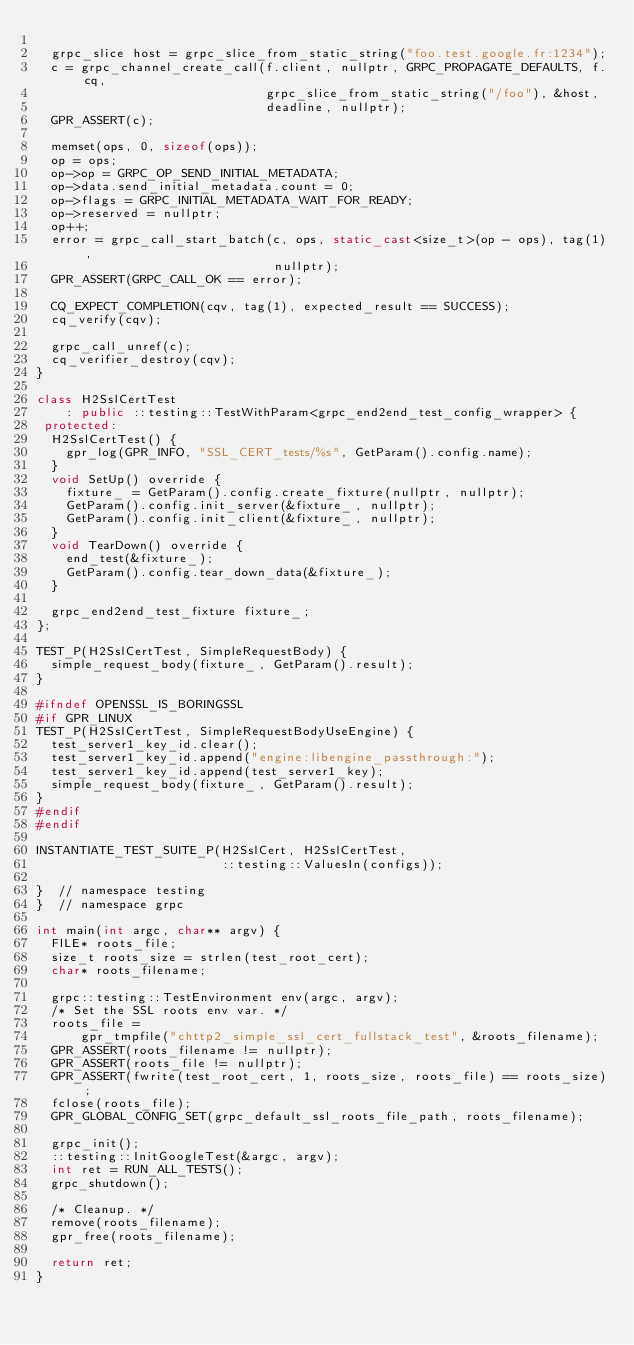Convert code to text. <code><loc_0><loc_0><loc_500><loc_500><_C++_>
  grpc_slice host = grpc_slice_from_static_string("foo.test.google.fr:1234");
  c = grpc_channel_create_call(f.client, nullptr, GRPC_PROPAGATE_DEFAULTS, f.cq,
                               grpc_slice_from_static_string("/foo"), &host,
                               deadline, nullptr);
  GPR_ASSERT(c);

  memset(ops, 0, sizeof(ops));
  op = ops;
  op->op = GRPC_OP_SEND_INITIAL_METADATA;
  op->data.send_initial_metadata.count = 0;
  op->flags = GRPC_INITIAL_METADATA_WAIT_FOR_READY;
  op->reserved = nullptr;
  op++;
  error = grpc_call_start_batch(c, ops, static_cast<size_t>(op - ops), tag(1),
                                nullptr);
  GPR_ASSERT(GRPC_CALL_OK == error);

  CQ_EXPECT_COMPLETION(cqv, tag(1), expected_result == SUCCESS);
  cq_verify(cqv);

  grpc_call_unref(c);
  cq_verifier_destroy(cqv);
}

class H2SslCertTest
    : public ::testing::TestWithParam<grpc_end2end_test_config_wrapper> {
 protected:
  H2SslCertTest() {
    gpr_log(GPR_INFO, "SSL_CERT_tests/%s", GetParam().config.name);
  }
  void SetUp() override {
    fixture_ = GetParam().config.create_fixture(nullptr, nullptr);
    GetParam().config.init_server(&fixture_, nullptr);
    GetParam().config.init_client(&fixture_, nullptr);
  }
  void TearDown() override {
    end_test(&fixture_);
    GetParam().config.tear_down_data(&fixture_);
  }

  grpc_end2end_test_fixture fixture_;
};

TEST_P(H2SslCertTest, SimpleRequestBody) {
  simple_request_body(fixture_, GetParam().result);
}

#ifndef OPENSSL_IS_BORINGSSL
#if GPR_LINUX
TEST_P(H2SslCertTest, SimpleRequestBodyUseEngine) {
  test_server1_key_id.clear();
  test_server1_key_id.append("engine:libengine_passthrough:");
  test_server1_key_id.append(test_server1_key);
  simple_request_body(fixture_, GetParam().result);
}
#endif
#endif

INSTANTIATE_TEST_SUITE_P(H2SslCert, H2SslCertTest,
                         ::testing::ValuesIn(configs));

}  // namespace testing
}  // namespace grpc

int main(int argc, char** argv) {
  FILE* roots_file;
  size_t roots_size = strlen(test_root_cert);
  char* roots_filename;

  grpc::testing::TestEnvironment env(argc, argv);
  /* Set the SSL roots env var. */
  roots_file =
      gpr_tmpfile("chttp2_simple_ssl_cert_fullstack_test", &roots_filename);
  GPR_ASSERT(roots_filename != nullptr);
  GPR_ASSERT(roots_file != nullptr);
  GPR_ASSERT(fwrite(test_root_cert, 1, roots_size, roots_file) == roots_size);
  fclose(roots_file);
  GPR_GLOBAL_CONFIG_SET(grpc_default_ssl_roots_file_path, roots_filename);

  grpc_init();
  ::testing::InitGoogleTest(&argc, argv);
  int ret = RUN_ALL_TESTS();
  grpc_shutdown();

  /* Cleanup. */
  remove(roots_filename);
  gpr_free(roots_filename);

  return ret;
}
</code> 